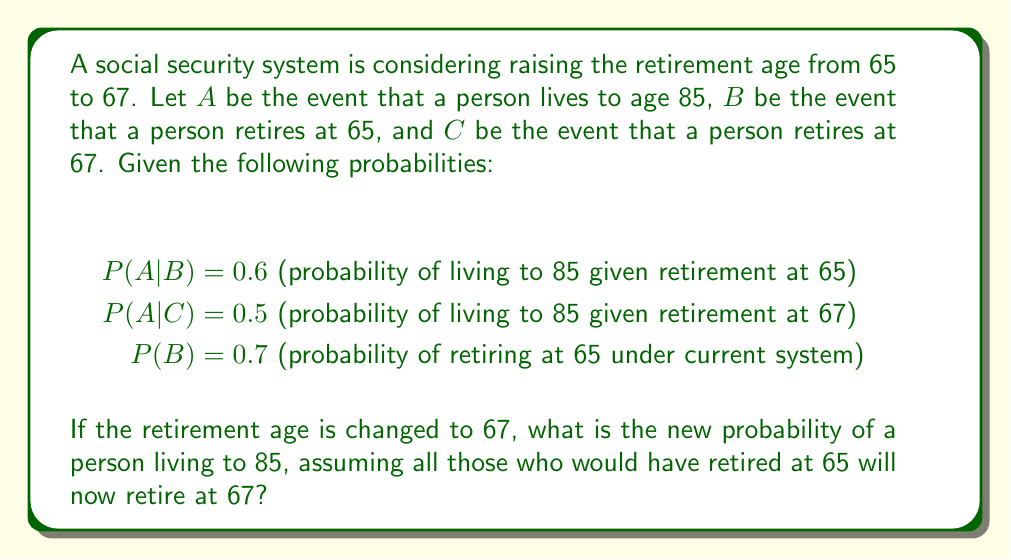Provide a solution to this math problem. To solve this problem, we'll use the law of total probability and conditional probability.

1) First, let's calculate P(A) under the current system:
   $$P(A) = P(A|B)P(B) + P(A|B^c)P(B^c)$$
   
   We know P(A|B) = 0.6 and P(B) = 0.7, but we don't know P(A|B^c). However, we don't need it for this problem.

2) Now, if the retirement age changes to 67, everyone who would have retired at 65 will now retire at 67. This means:
   P(C) in the new system = P(B) in the old system = 0.7

3) We can now calculate the new P(A) using the law of total probability:
   $$P_{new}(A) = P(A|C)P(C) + P(A|C^c)P(C^c)$$

4) We know:
   P(A|C) = 0.5
   P(C) = 0.7
   P(C^c) = 1 - P(C) = 0.3

5) Substituting these values:
   $$P_{new}(A) = 0.5 * 0.7 + P(A|C^c) * 0.3$$

6) We don't know P(A|C^c), but we can calculate it using the fact that the overall probability of A should remain the same (assuming the change in retirement age doesn't affect longevity):
   $$0.6 * 0.7 + P(A|B^c) * 0.3 = 0.5 * 0.7 + P(A|C^c) * 0.3$$

7) Solving this equation:
   $$0.42 + 0.3P(A|B^c) = 0.35 + 0.3P(A|C^c)$$
   $$P(A|B^c) = P(A|C^c) - 0.2333$$

8) Substituting this back into the equation for P_{new}(A):
   $$P_{new}(A) = 0.5 * 0.7 + (P(A|B^c) + 0.2333) * 0.3$$
   $$P_{new}(A) = 0.35 + 0.3P(A|B^c) + 0.07$$
   $$P_{new}(A) = 0.42 + 0.3P(A|B^c)$$

9) This is exactly the same as the original P(A), which makes sense as we assumed changing the retirement age doesn't affect longevity.

Therefore, the new probability of a person living to 85 remains unchanged at:
$$P_{new}(A) = 0.6 * 0.7 + P(A|B^c) * 0.3 = 0.42 + 0.3P(A|B^c)$$
Answer: 0.42 + 0.3P(A|B^c) 